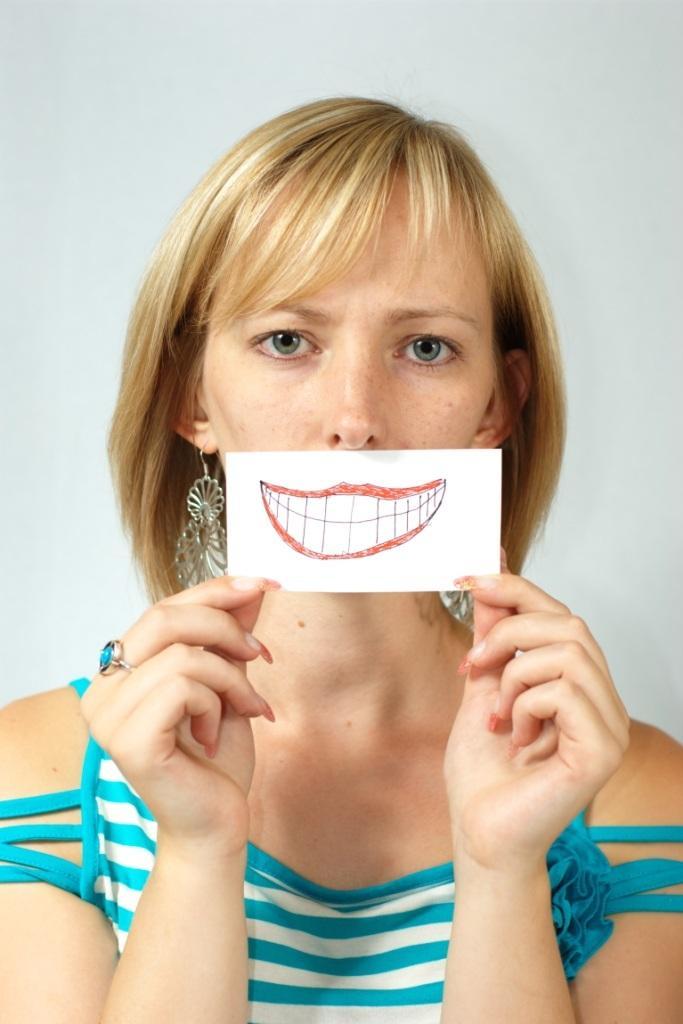Could you give a brief overview of what you see in this image? In this picture there is a woman holding a paper, on this paper we can see painting of a mouth. In the background of the image it is white. 